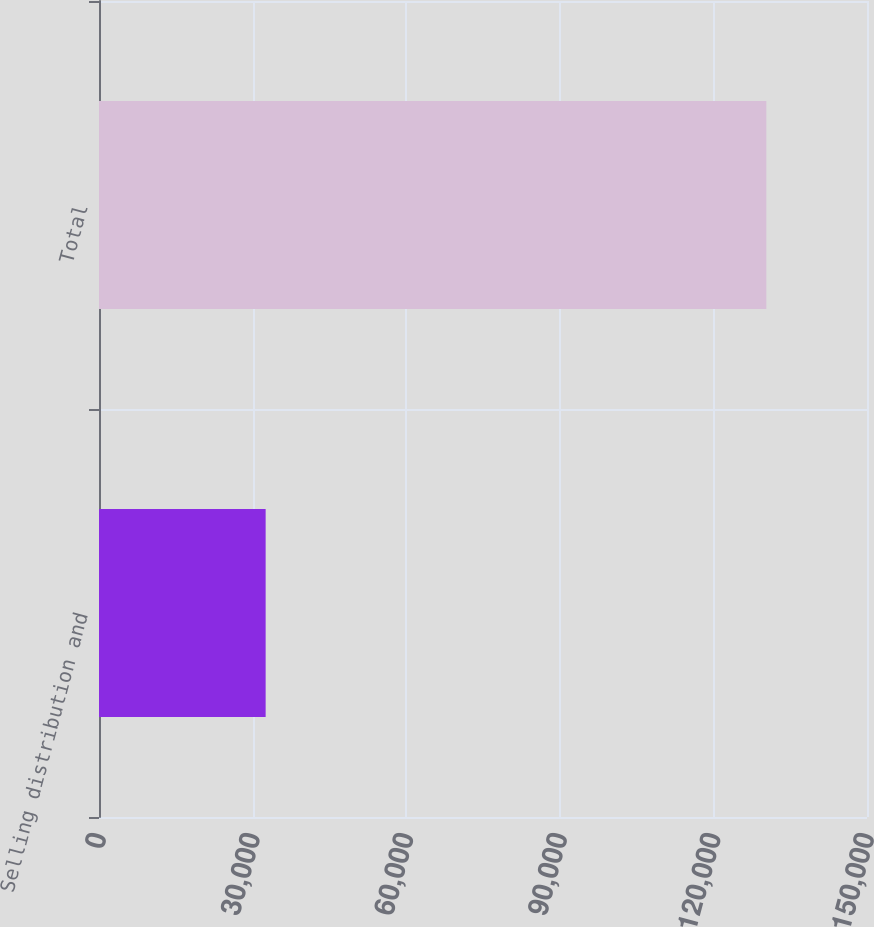Convert chart to OTSL. <chart><loc_0><loc_0><loc_500><loc_500><bar_chart><fcel>Selling distribution and<fcel>Total<nl><fcel>32547<fcel>130339<nl></chart> 